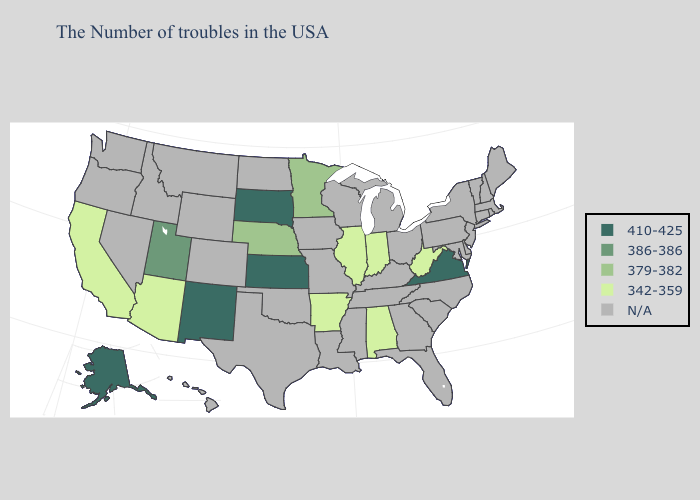Name the states that have a value in the range N/A?
Short answer required. Maine, Massachusetts, Rhode Island, New Hampshire, Vermont, Connecticut, New York, New Jersey, Delaware, Maryland, Pennsylvania, North Carolina, South Carolina, Ohio, Florida, Georgia, Michigan, Kentucky, Tennessee, Wisconsin, Mississippi, Louisiana, Missouri, Iowa, Oklahoma, Texas, North Dakota, Wyoming, Colorado, Montana, Idaho, Nevada, Washington, Oregon, Hawaii. What is the highest value in the USA?
Keep it brief. 410-425. Which states have the highest value in the USA?
Concise answer only. Virginia, Kansas, South Dakota, New Mexico, Alaska. Among the states that border North Carolina , which have the highest value?
Answer briefly. Virginia. What is the value of Florida?
Give a very brief answer. N/A. Which states have the highest value in the USA?
Answer briefly. Virginia, Kansas, South Dakota, New Mexico, Alaska. Does South Dakota have the highest value in the USA?
Be succinct. Yes. What is the value of Oregon?
Keep it brief. N/A. Which states hav the highest value in the South?
Write a very short answer. Virginia. 